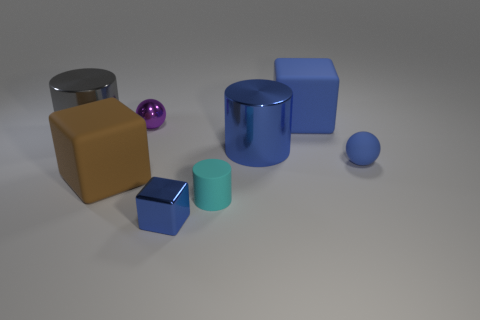Subtract all blue blocks. How many were subtracted if there are1blue blocks left? 1 Add 1 spheres. How many objects exist? 9 Subtract all cylinders. How many objects are left? 5 Add 8 tiny blocks. How many tiny blocks exist? 9 Subtract 0 brown cylinders. How many objects are left? 8 Subtract all blue objects. Subtract all brown blocks. How many objects are left? 3 Add 2 large blue things. How many large blue things are left? 4 